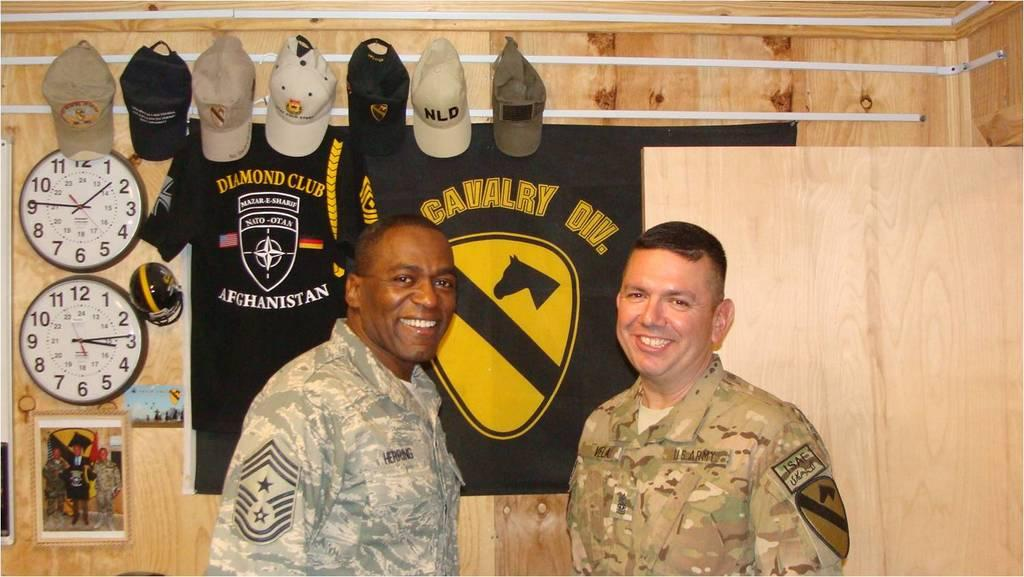Provide a one-sentence caption for the provided image. Two uniformed men pose in front of a banner for a Cavalry Division. 